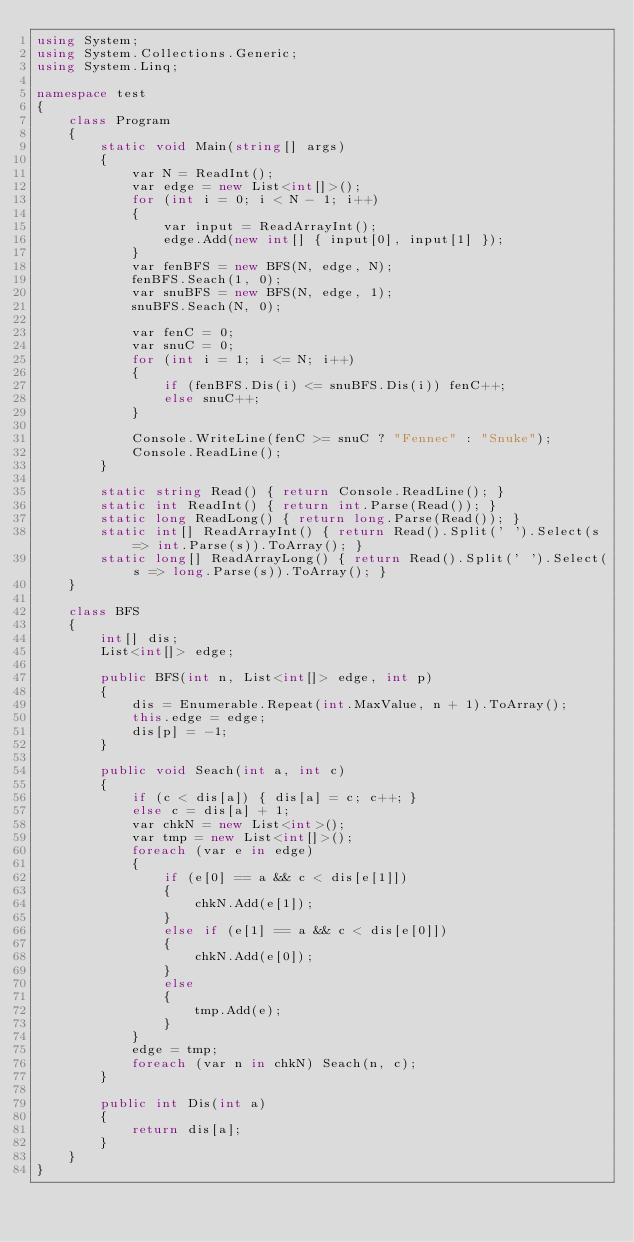Convert code to text. <code><loc_0><loc_0><loc_500><loc_500><_C#_>using System;
using System.Collections.Generic;
using System.Linq;

namespace test
{
    class Program
    {
        static void Main(string[] args)
        {
            var N = ReadInt();
            var edge = new List<int[]>();
            for (int i = 0; i < N - 1; i++)
            {
                var input = ReadArrayInt();
                edge.Add(new int[] { input[0], input[1] });
            }
            var fenBFS = new BFS(N, edge, N);
            fenBFS.Seach(1, 0);
            var snuBFS = new BFS(N, edge, 1);
            snuBFS.Seach(N, 0);

            var fenC = 0;
            var snuC = 0;
            for (int i = 1; i <= N; i++)
            {
                if (fenBFS.Dis(i) <= snuBFS.Dis(i)) fenC++;
                else snuC++;
            }

            Console.WriteLine(fenC >= snuC ? "Fennec" : "Snuke");
            Console.ReadLine();
        }

        static string Read() { return Console.ReadLine(); }
        static int ReadInt() { return int.Parse(Read()); }
        static long ReadLong() { return long.Parse(Read()); }
        static int[] ReadArrayInt() { return Read().Split(' ').Select(s => int.Parse(s)).ToArray(); }
        static long[] ReadArrayLong() { return Read().Split(' ').Select(s => long.Parse(s)).ToArray(); }
    }

    class BFS
    {
        int[] dis;
        List<int[]> edge;

        public BFS(int n, List<int[]> edge, int p)
        {
            dis = Enumerable.Repeat(int.MaxValue, n + 1).ToArray();
            this.edge = edge;
            dis[p] = -1;
        }

        public void Seach(int a, int c)
        {
            if (c < dis[a]) { dis[a] = c; c++; }
            else c = dis[a] + 1;
            var chkN = new List<int>();
            var tmp = new List<int[]>();
            foreach (var e in edge)
            {
                if (e[0] == a && c < dis[e[1]])
                {
                    chkN.Add(e[1]);
                }
                else if (e[1] == a && c < dis[e[0]])
                {
                    chkN.Add(e[0]);
                }
                else
                {
                    tmp.Add(e);
                }
            }
            edge = tmp;
            foreach (var n in chkN) Seach(n, c);
        }

        public int Dis(int a)
        {
            return dis[a];
        }
    }
}</code> 